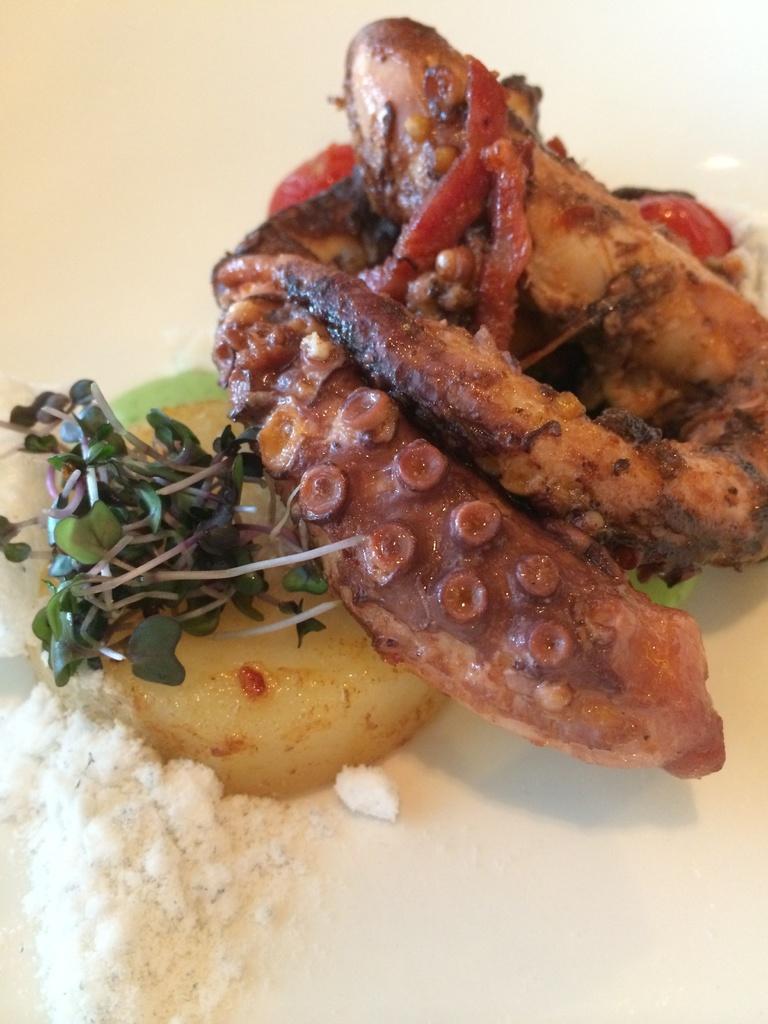Can you describe this image briefly? In this picture we can see food on the platform. 